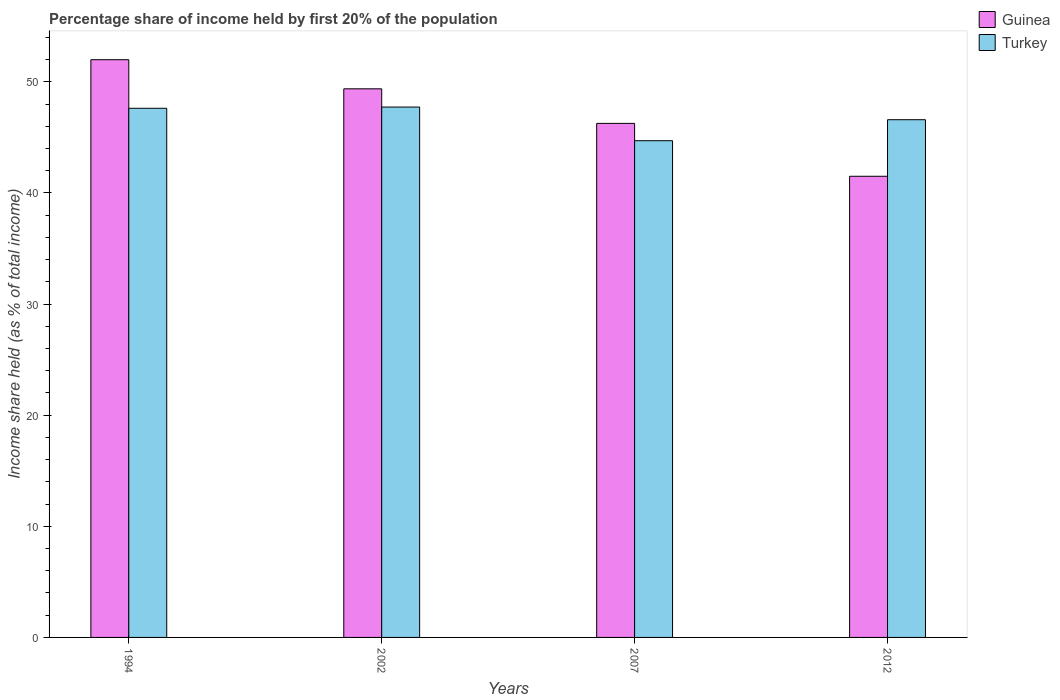How many different coloured bars are there?
Provide a succinct answer. 2. How many groups of bars are there?
Your answer should be very brief. 4. Are the number of bars per tick equal to the number of legend labels?
Your answer should be very brief. Yes. How many bars are there on the 3rd tick from the left?
Offer a terse response. 2. In how many cases, is the number of bars for a given year not equal to the number of legend labels?
Give a very brief answer. 0. What is the share of income held by first 20% of the population in Turkey in 2002?
Provide a succinct answer. 47.73. Across all years, what is the maximum share of income held by first 20% of the population in Turkey?
Provide a short and direct response. 47.73. Across all years, what is the minimum share of income held by first 20% of the population in Guinea?
Offer a terse response. 41.5. In which year was the share of income held by first 20% of the population in Turkey maximum?
Your response must be concise. 2002. What is the total share of income held by first 20% of the population in Turkey in the graph?
Give a very brief answer. 186.64. What is the difference between the share of income held by first 20% of the population in Guinea in 1994 and that in 2012?
Ensure brevity in your answer.  10.49. What is the difference between the share of income held by first 20% of the population in Turkey in 2002 and the share of income held by first 20% of the population in Guinea in 1994?
Your answer should be very brief. -4.26. What is the average share of income held by first 20% of the population in Turkey per year?
Make the answer very short. 46.66. In the year 1994, what is the difference between the share of income held by first 20% of the population in Guinea and share of income held by first 20% of the population in Turkey?
Your answer should be compact. 4.37. What is the ratio of the share of income held by first 20% of the population in Guinea in 2002 to that in 2012?
Provide a succinct answer. 1.19. Is the share of income held by first 20% of the population in Guinea in 2002 less than that in 2007?
Make the answer very short. No. Is the difference between the share of income held by first 20% of the population in Guinea in 2002 and 2012 greater than the difference between the share of income held by first 20% of the population in Turkey in 2002 and 2012?
Your answer should be compact. Yes. What is the difference between the highest and the second highest share of income held by first 20% of the population in Turkey?
Keep it short and to the point. 0.11. What is the difference between the highest and the lowest share of income held by first 20% of the population in Guinea?
Keep it short and to the point. 10.49. What does the 1st bar from the left in 1994 represents?
Ensure brevity in your answer.  Guinea. What does the 2nd bar from the right in 2002 represents?
Keep it short and to the point. Guinea. What is the difference between two consecutive major ticks on the Y-axis?
Provide a short and direct response. 10. Are the values on the major ticks of Y-axis written in scientific E-notation?
Keep it short and to the point. No. Does the graph contain any zero values?
Provide a succinct answer. No. Where does the legend appear in the graph?
Keep it short and to the point. Top right. How many legend labels are there?
Your answer should be compact. 2. What is the title of the graph?
Provide a short and direct response. Percentage share of income held by first 20% of the population. Does "Faeroe Islands" appear as one of the legend labels in the graph?
Provide a succinct answer. No. What is the label or title of the Y-axis?
Keep it short and to the point. Income share held (as % of total income). What is the Income share held (as % of total income) of Guinea in 1994?
Your response must be concise. 51.99. What is the Income share held (as % of total income) in Turkey in 1994?
Provide a succinct answer. 47.62. What is the Income share held (as % of total income) of Guinea in 2002?
Ensure brevity in your answer.  49.37. What is the Income share held (as % of total income) in Turkey in 2002?
Provide a succinct answer. 47.73. What is the Income share held (as % of total income) of Guinea in 2007?
Your answer should be compact. 46.26. What is the Income share held (as % of total income) in Turkey in 2007?
Provide a short and direct response. 44.7. What is the Income share held (as % of total income) of Guinea in 2012?
Provide a succinct answer. 41.5. What is the Income share held (as % of total income) of Turkey in 2012?
Your answer should be compact. 46.59. Across all years, what is the maximum Income share held (as % of total income) of Guinea?
Your answer should be compact. 51.99. Across all years, what is the maximum Income share held (as % of total income) in Turkey?
Provide a short and direct response. 47.73. Across all years, what is the minimum Income share held (as % of total income) in Guinea?
Ensure brevity in your answer.  41.5. Across all years, what is the minimum Income share held (as % of total income) in Turkey?
Provide a short and direct response. 44.7. What is the total Income share held (as % of total income) in Guinea in the graph?
Give a very brief answer. 189.12. What is the total Income share held (as % of total income) in Turkey in the graph?
Give a very brief answer. 186.64. What is the difference between the Income share held (as % of total income) in Guinea in 1994 and that in 2002?
Keep it short and to the point. 2.62. What is the difference between the Income share held (as % of total income) of Turkey in 1994 and that in 2002?
Provide a succinct answer. -0.11. What is the difference between the Income share held (as % of total income) of Guinea in 1994 and that in 2007?
Give a very brief answer. 5.73. What is the difference between the Income share held (as % of total income) of Turkey in 1994 and that in 2007?
Offer a terse response. 2.92. What is the difference between the Income share held (as % of total income) of Guinea in 1994 and that in 2012?
Offer a very short reply. 10.49. What is the difference between the Income share held (as % of total income) of Guinea in 2002 and that in 2007?
Provide a short and direct response. 3.11. What is the difference between the Income share held (as % of total income) in Turkey in 2002 and that in 2007?
Give a very brief answer. 3.03. What is the difference between the Income share held (as % of total income) in Guinea in 2002 and that in 2012?
Offer a terse response. 7.87. What is the difference between the Income share held (as % of total income) in Turkey in 2002 and that in 2012?
Your response must be concise. 1.14. What is the difference between the Income share held (as % of total income) in Guinea in 2007 and that in 2012?
Keep it short and to the point. 4.76. What is the difference between the Income share held (as % of total income) of Turkey in 2007 and that in 2012?
Offer a terse response. -1.89. What is the difference between the Income share held (as % of total income) of Guinea in 1994 and the Income share held (as % of total income) of Turkey in 2002?
Your response must be concise. 4.26. What is the difference between the Income share held (as % of total income) in Guinea in 1994 and the Income share held (as % of total income) in Turkey in 2007?
Give a very brief answer. 7.29. What is the difference between the Income share held (as % of total income) in Guinea in 1994 and the Income share held (as % of total income) in Turkey in 2012?
Give a very brief answer. 5.4. What is the difference between the Income share held (as % of total income) in Guinea in 2002 and the Income share held (as % of total income) in Turkey in 2007?
Offer a very short reply. 4.67. What is the difference between the Income share held (as % of total income) of Guinea in 2002 and the Income share held (as % of total income) of Turkey in 2012?
Your answer should be compact. 2.78. What is the difference between the Income share held (as % of total income) in Guinea in 2007 and the Income share held (as % of total income) in Turkey in 2012?
Ensure brevity in your answer.  -0.33. What is the average Income share held (as % of total income) in Guinea per year?
Keep it short and to the point. 47.28. What is the average Income share held (as % of total income) in Turkey per year?
Keep it short and to the point. 46.66. In the year 1994, what is the difference between the Income share held (as % of total income) of Guinea and Income share held (as % of total income) of Turkey?
Offer a very short reply. 4.37. In the year 2002, what is the difference between the Income share held (as % of total income) of Guinea and Income share held (as % of total income) of Turkey?
Make the answer very short. 1.64. In the year 2007, what is the difference between the Income share held (as % of total income) of Guinea and Income share held (as % of total income) of Turkey?
Your answer should be compact. 1.56. In the year 2012, what is the difference between the Income share held (as % of total income) of Guinea and Income share held (as % of total income) of Turkey?
Give a very brief answer. -5.09. What is the ratio of the Income share held (as % of total income) of Guinea in 1994 to that in 2002?
Offer a terse response. 1.05. What is the ratio of the Income share held (as % of total income) in Turkey in 1994 to that in 2002?
Ensure brevity in your answer.  1. What is the ratio of the Income share held (as % of total income) in Guinea in 1994 to that in 2007?
Provide a succinct answer. 1.12. What is the ratio of the Income share held (as % of total income) of Turkey in 1994 to that in 2007?
Make the answer very short. 1.07. What is the ratio of the Income share held (as % of total income) of Guinea in 1994 to that in 2012?
Make the answer very short. 1.25. What is the ratio of the Income share held (as % of total income) in Turkey in 1994 to that in 2012?
Make the answer very short. 1.02. What is the ratio of the Income share held (as % of total income) of Guinea in 2002 to that in 2007?
Your answer should be very brief. 1.07. What is the ratio of the Income share held (as % of total income) of Turkey in 2002 to that in 2007?
Keep it short and to the point. 1.07. What is the ratio of the Income share held (as % of total income) in Guinea in 2002 to that in 2012?
Your response must be concise. 1.19. What is the ratio of the Income share held (as % of total income) in Turkey in 2002 to that in 2012?
Give a very brief answer. 1.02. What is the ratio of the Income share held (as % of total income) in Guinea in 2007 to that in 2012?
Give a very brief answer. 1.11. What is the ratio of the Income share held (as % of total income) of Turkey in 2007 to that in 2012?
Offer a very short reply. 0.96. What is the difference between the highest and the second highest Income share held (as % of total income) of Guinea?
Keep it short and to the point. 2.62. What is the difference between the highest and the second highest Income share held (as % of total income) of Turkey?
Your answer should be very brief. 0.11. What is the difference between the highest and the lowest Income share held (as % of total income) of Guinea?
Make the answer very short. 10.49. What is the difference between the highest and the lowest Income share held (as % of total income) of Turkey?
Your answer should be very brief. 3.03. 